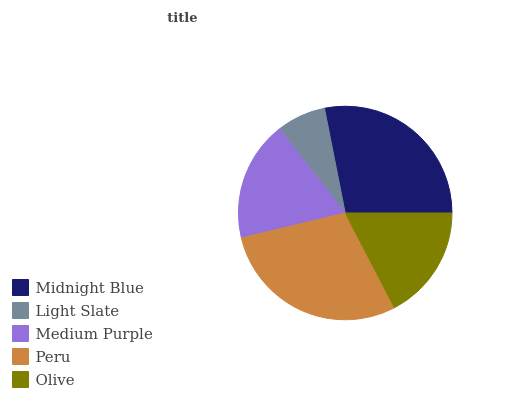Is Light Slate the minimum?
Answer yes or no. Yes. Is Peru the maximum?
Answer yes or no. Yes. Is Medium Purple the minimum?
Answer yes or no. No. Is Medium Purple the maximum?
Answer yes or no. No. Is Medium Purple greater than Light Slate?
Answer yes or no. Yes. Is Light Slate less than Medium Purple?
Answer yes or no. Yes. Is Light Slate greater than Medium Purple?
Answer yes or no. No. Is Medium Purple less than Light Slate?
Answer yes or no. No. Is Medium Purple the high median?
Answer yes or no. Yes. Is Medium Purple the low median?
Answer yes or no. Yes. Is Olive the high median?
Answer yes or no. No. Is Midnight Blue the low median?
Answer yes or no. No. 